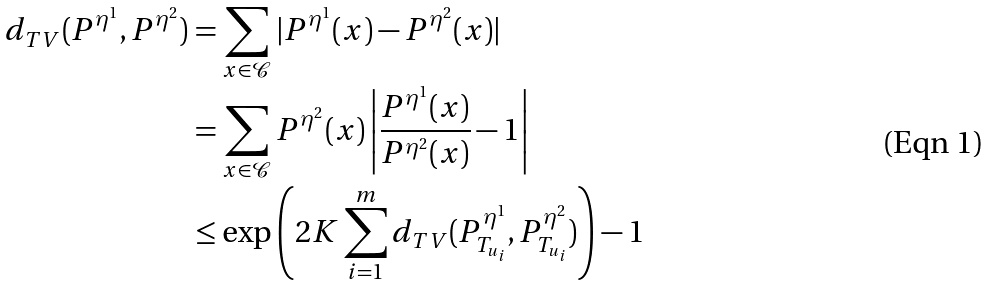Convert formula to latex. <formula><loc_0><loc_0><loc_500><loc_500>d _ { T V } ( P ^ { \eta ^ { 1 } } , P ^ { \eta ^ { 2 } } ) & = \sum _ { x \in \mathcal { C } } | P ^ { \eta ^ { 1 } } ( x ) - P ^ { \eta ^ { 2 } } ( x ) | \\ & = \sum _ { x \in \mathcal { C } } P ^ { \eta ^ { 2 } } ( x ) \left | \frac { P ^ { \eta ^ { 1 } } ( x ) } { P ^ { \eta ^ { 2 } } ( x ) } - 1 \right | \\ & \leq \exp \left ( 2 K \sum _ { i = 1 } ^ { m } d _ { T V } ( P _ { T _ { u _ { i } } } ^ { \eta ^ { 1 } } , P _ { T _ { u _ { i } } } ^ { \eta ^ { 2 } } ) \right ) - 1</formula> 